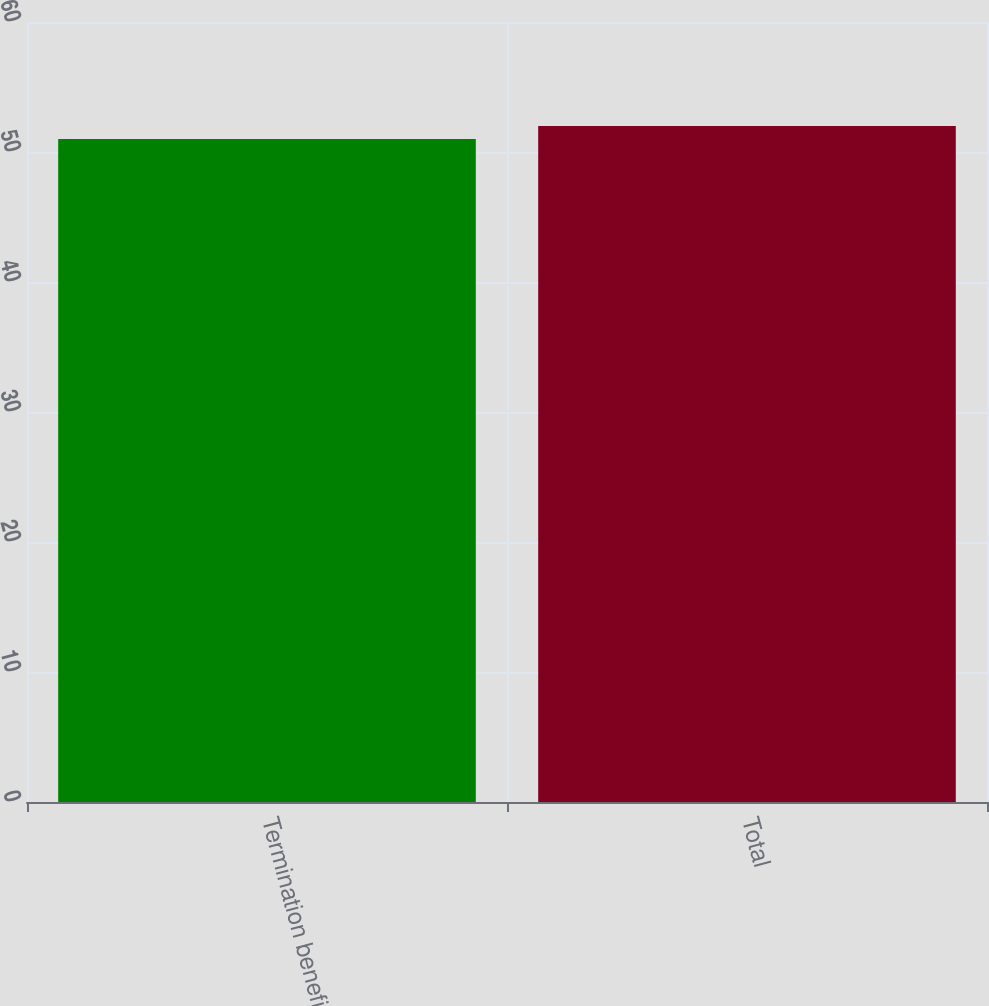<chart> <loc_0><loc_0><loc_500><loc_500><bar_chart><fcel>Termination benefits<fcel>Total<nl><fcel>51<fcel>52<nl></chart> 